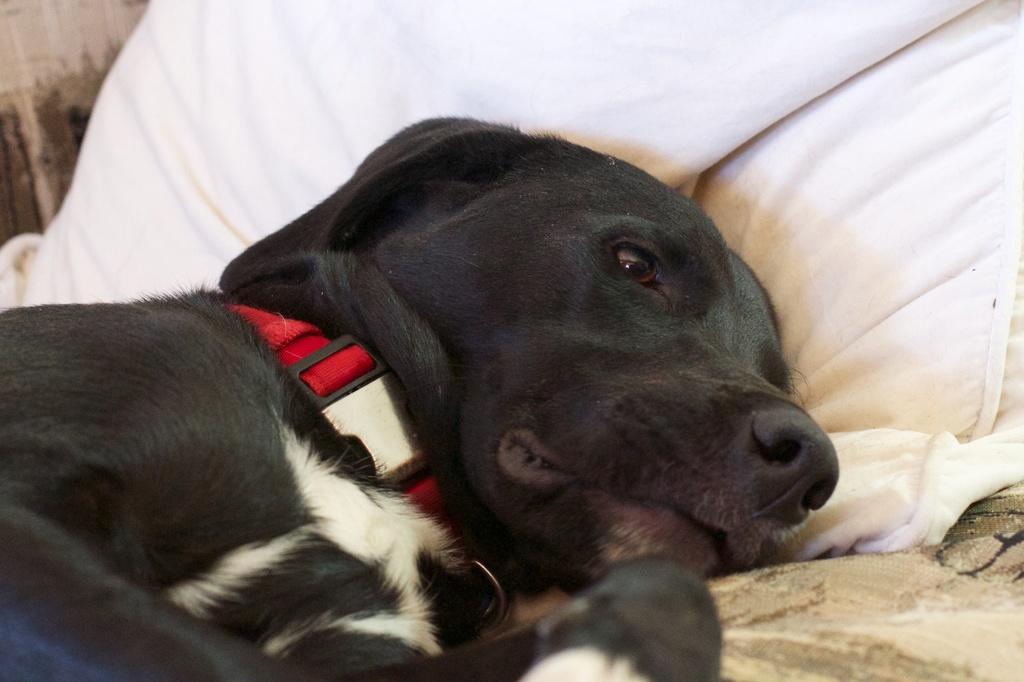How would you summarize this image in a sentence or two? In the foreground of this image, there is a black dog lying on a bed and on the top, there is a white pillow and there is a red belt to its neck. 